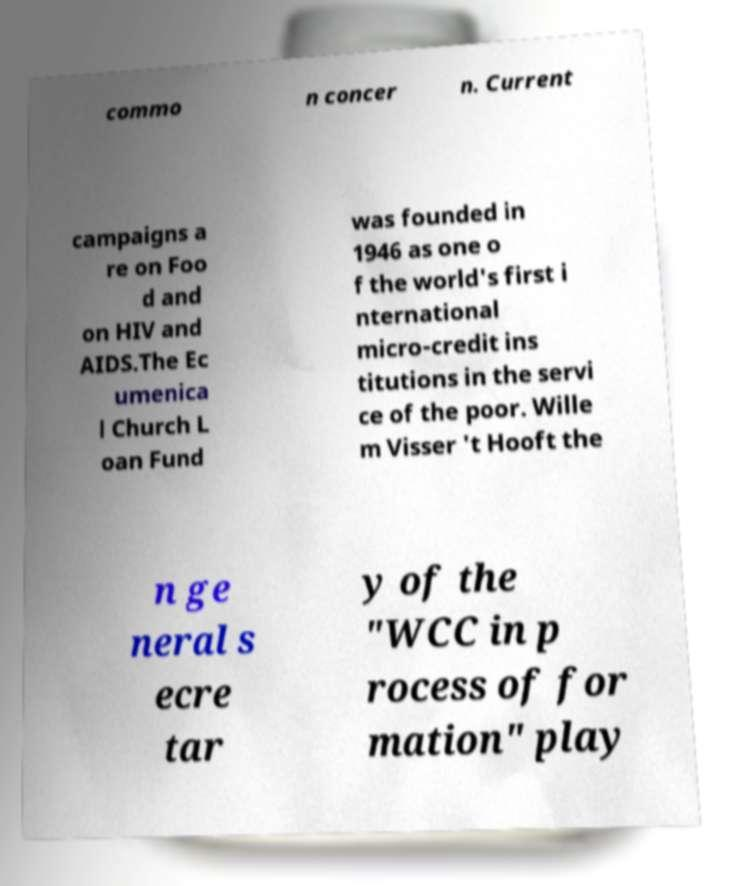Please identify and transcribe the text found in this image. commo n concer n. Current campaigns a re on Foo d and on HIV and AIDS.The Ec umenica l Church L oan Fund was founded in 1946 as one o f the world's first i nternational micro-credit ins titutions in the servi ce of the poor. Wille m Visser 't Hooft the n ge neral s ecre tar y of the "WCC in p rocess of for mation" play 